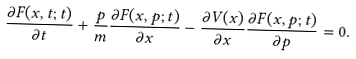Convert formula to latex. <formula><loc_0><loc_0><loc_500><loc_500>\frac { \partial F ( x , t ; t ) } { \partial t } + \frac { p } { m } \frac { \partial F ( x , p ; t ) } { \partial x } - \frac { \partial V ( x ) } { \partial x } \frac { \partial F ( x , p ; t ) } { \partial p } = 0 .</formula> 